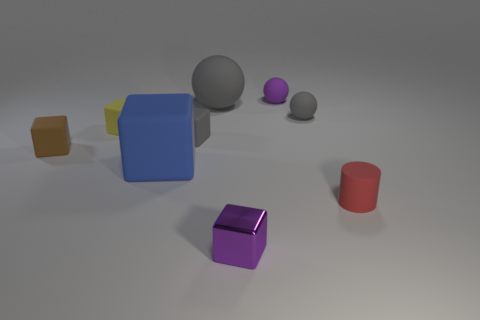Subtract all gray balls. How many were subtracted if there are1gray balls left? 1 Subtract all tiny rubber spheres. How many spheres are left? 1 Subtract all purple cylinders. How many gray balls are left? 2 Subtract all purple cubes. How many cubes are left? 4 Subtract all brown cubes. Subtract all cyan cylinders. How many cubes are left? 4 Subtract all blocks. How many objects are left? 4 Subtract all blue cylinders. Subtract all big blue blocks. How many objects are left? 8 Add 9 tiny brown cubes. How many tiny brown cubes are left? 10 Add 9 red cubes. How many red cubes exist? 9 Subtract 0 red blocks. How many objects are left? 9 